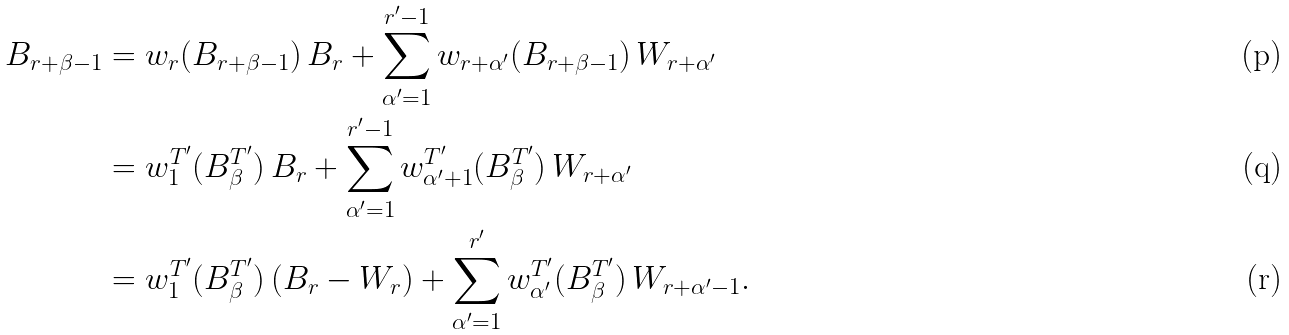<formula> <loc_0><loc_0><loc_500><loc_500>B _ { r + \beta - 1 } & = w _ { r } ( B _ { r + \beta - 1 } ) \, B _ { r } + \sum _ { \alpha ^ { \prime } = 1 } ^ { r ^ { \prime } - 1 } w _ { r + \alpha ^ { \prime } } ( B _ { r + \beta - 1 } ) \, W _ { r + \alpha ^ { \prime } } \\ & = w _ { 1 } ^ { T ^ { \prime } } ( B _ { \beta } ^ { T ^ { \prime } } ) \, B _ { r } + \sum _ { \alpha ^ { \prime } = 1 } ^ { r ^ { \prime } - 1 } w _ { \alpha ^ { \prime } + 1 } ^ { T ^ { \prime } } ( B _ { \beta } ^ { T ^ { \prime } } ) \, W _ { r + \alpha ^ { \prime } } \\ & = w _ { 1 } ^ { T ^ { \prime } } ( B _ { \beta } ^ { T ^ { \prime } } ) \, ( B _ { r } - W _ { r } ) + \sum _ { \alpha ^ { \prime } = 1 } ^ { r ^ { \prime } } w _ { \alpha ^ { \prime } } ^ { T ^ { \prime } } ( B _ { \beta } ^ { T ^ { \prime } } ) \, W _ { r + \alpha ^ { \prime } - 1 } .</formula> 